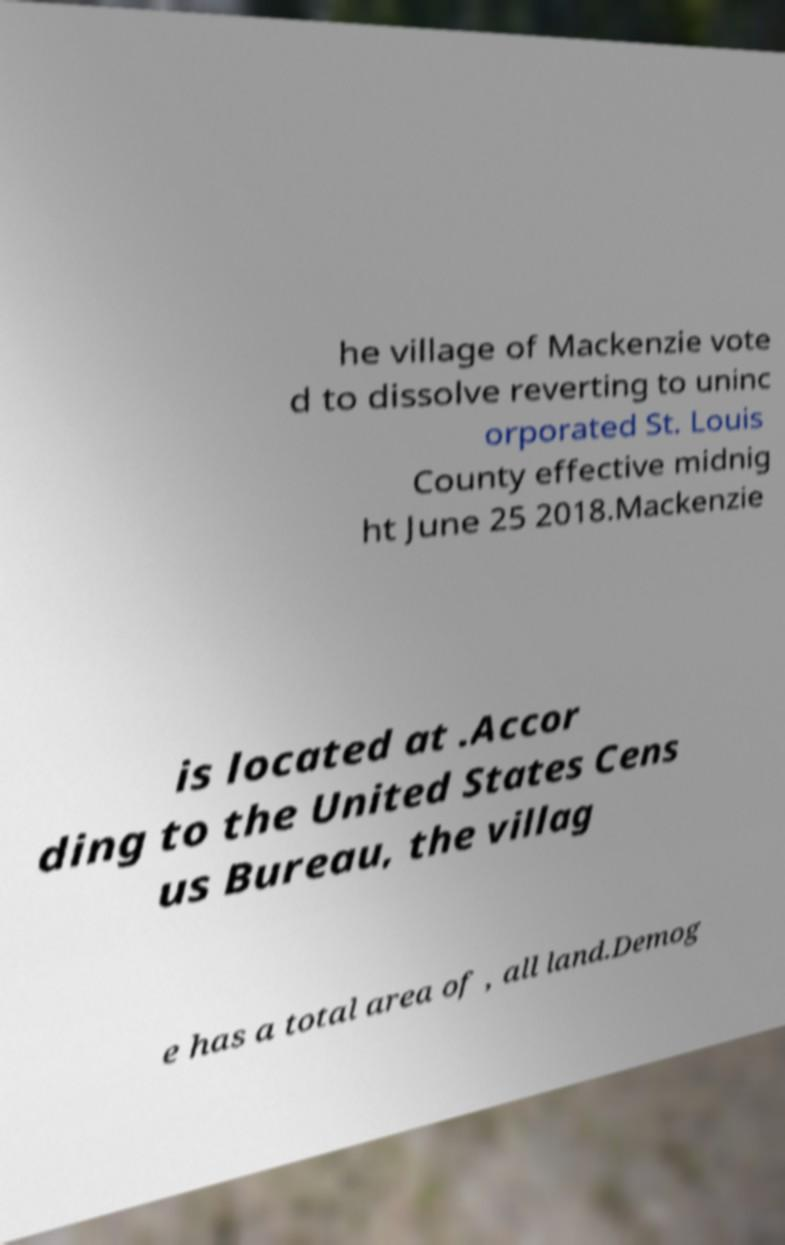Please identify and transcribe the text found in this image. he village of Mackenzie vote d to dissolve reverting to uninc orporated St. Louis County effective midnig ht June 25 2018.Mackenzie is located at .Accor ding to the United States Cens us Bureau, the villag e has a total area of , all land.Demog 